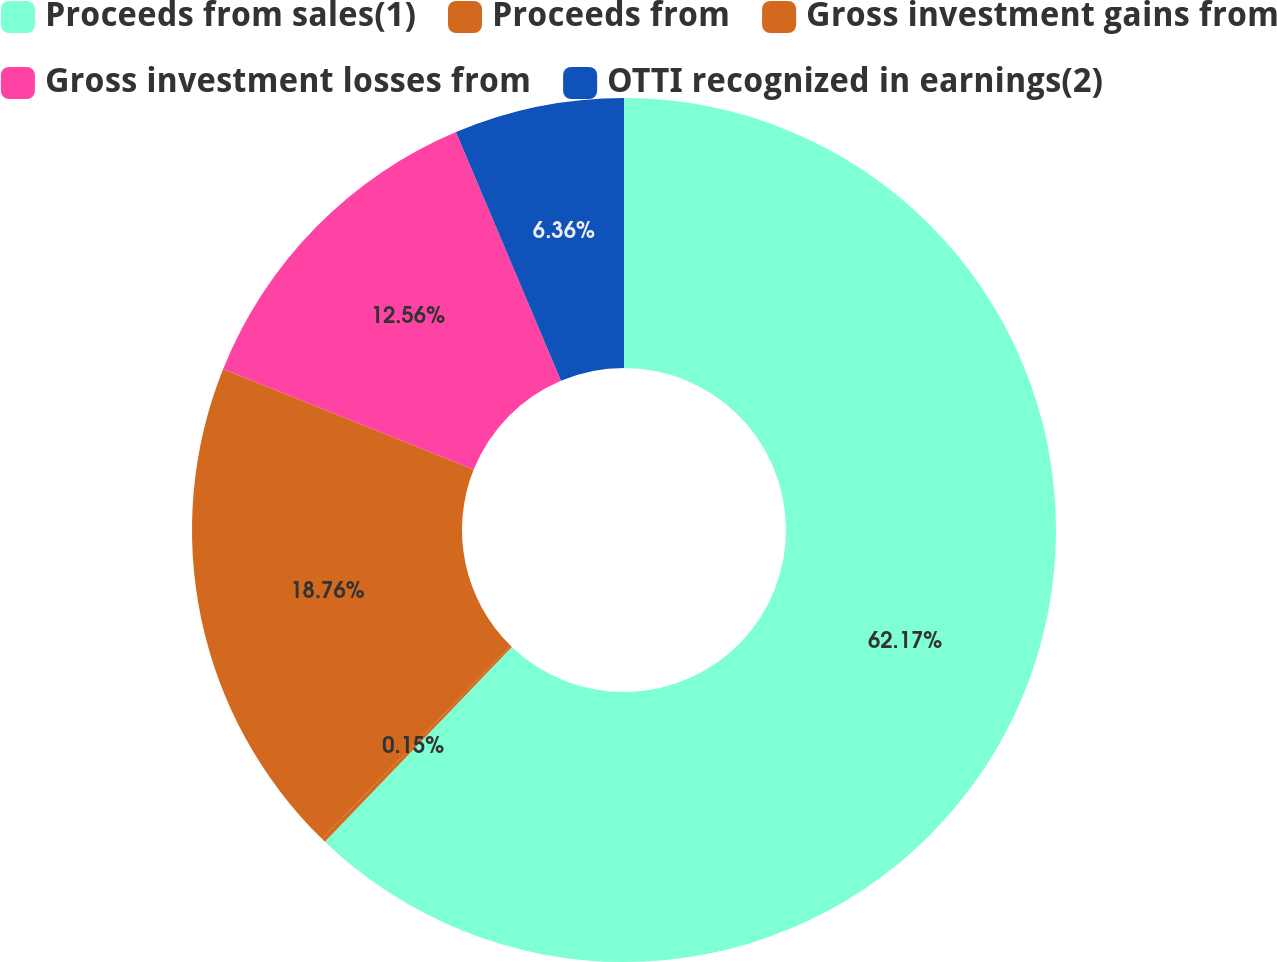Convert chart. <chart><loc_0><loc_0><loc_500><loc_500><pie_chart><fcel>Proceeds from sales(1)<fcel>Proceeds from<fcel>Gross investment gains from<fcel>Gross investment losses from<fcel>OTTI recognized in earnings(2)<nl><fcel>62.18%<fcel>0.15%<fcel>18.76%<fcel>12.56%<fcel>6.36%<nl></chart> 